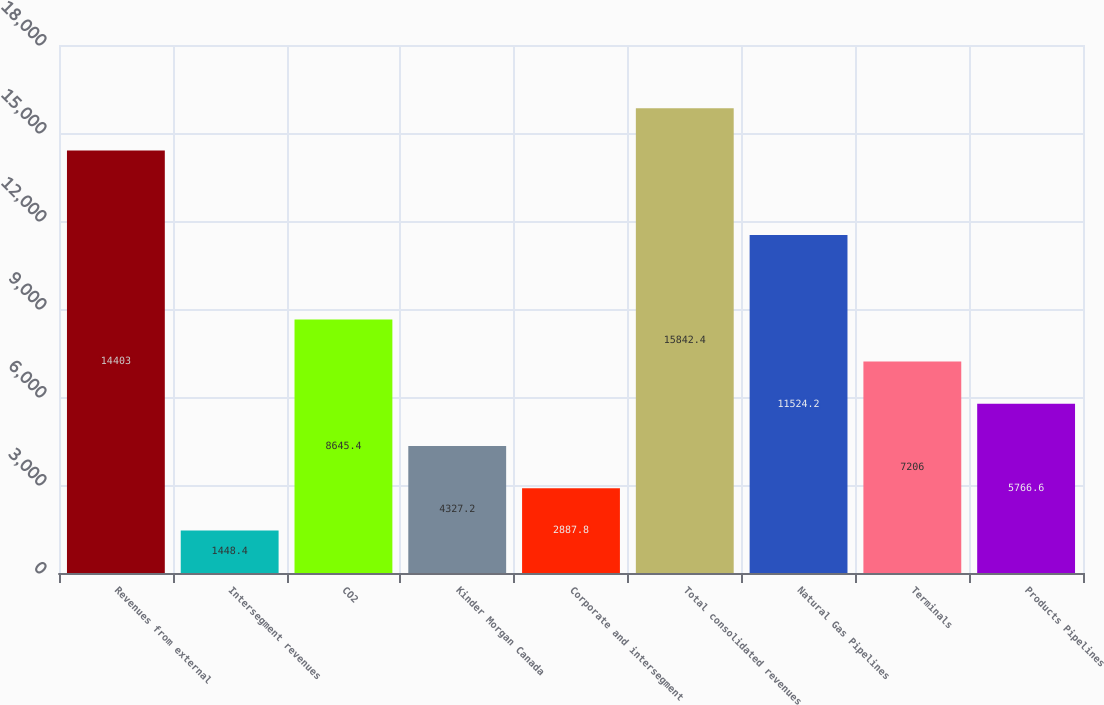Convert chart to OTSL. <chart><loc_0><loc_0><loc_500><loc_500><bar_chart><fcel>Revenues from external<fcel>Intersegment revenues<fcel>CO2<fcel>Kinder Morgan Canada<fcel>Corporate and intersegment<fcel>Total consolidated revenues<fcel>Natural Gas Pipelines<fcel>Terminals<fcel>Products Pipelines<nl><fcel>14403<fcel>1448.4<fcel>8645.4<fcel>4327.2<fcel>2887.8<fcel>15842.4<fcel>11524.2<fcel>7206<fcel>5766.6<nl></chart> 